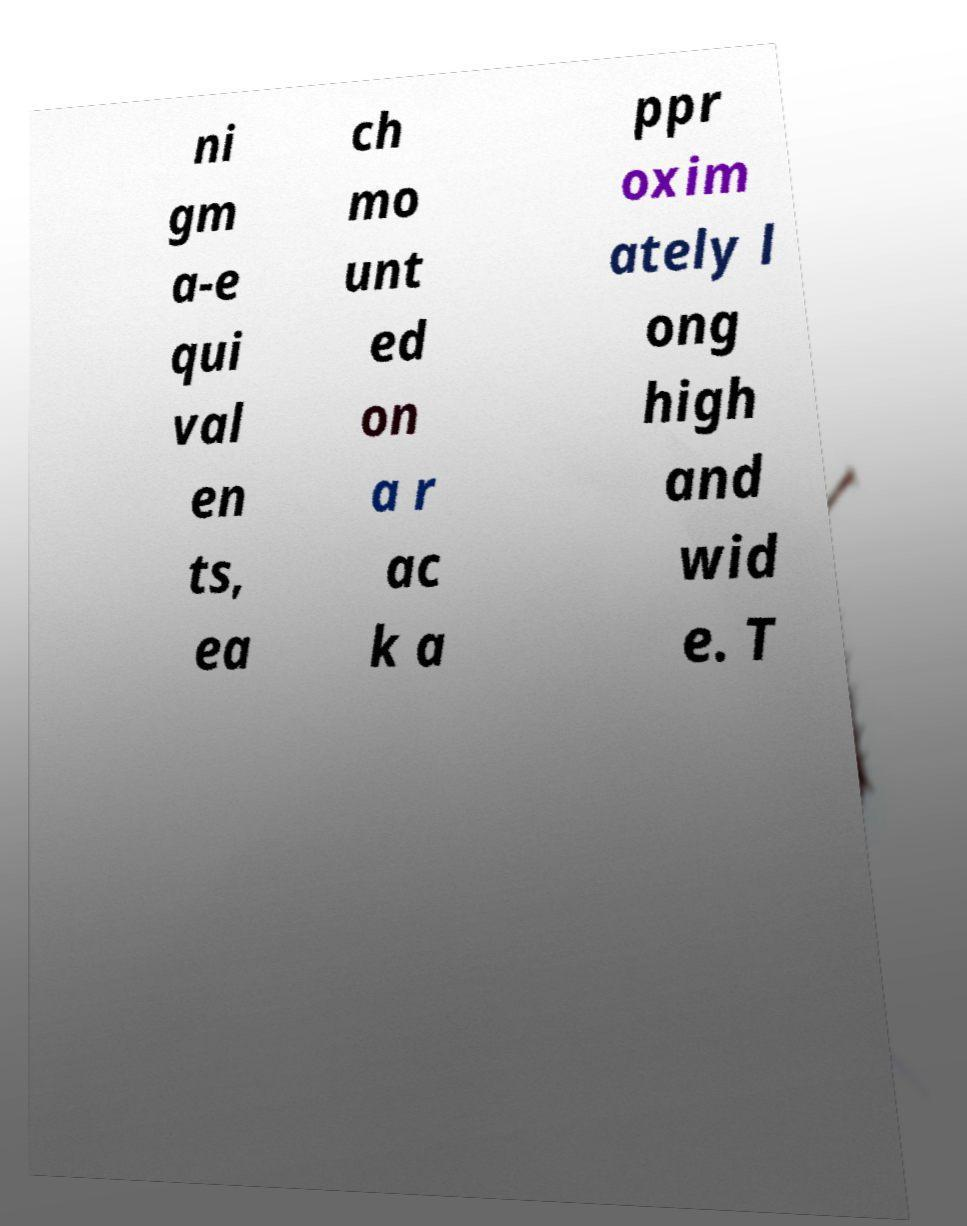Please identify and transcribe the text found in this image. ni gm a-e qui val en ts, ea ch mo unt ed on a r ac k a ppr oxim ately l ong high and wid e. T 